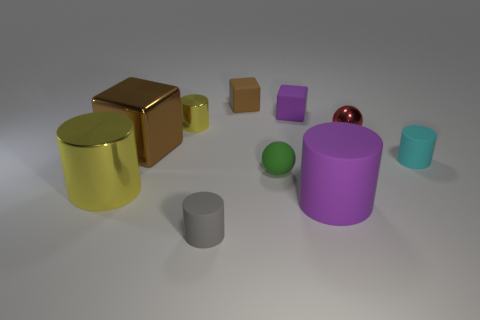There is a brown object that is right of the small yellow cylinder; what material is it?
Offer a terse response. Rubber. Are there any other things that have the same shape as the gray object?
Your answer should be compact. Yes. What number of metal objects are red spheres or yellow blocks?
Offer a very short reply. 1. Are there fewer brown blocks on the right side of the red shiny ball than cyan cylinders?
Keep it short and to the point. Yes. What shape is the yellow object that is right of the cylinder that is to the left of the brown metallic object behind the tiny cyan matte cylinder?
Ensure brevity in your answer.  Cylinder. Is the color of the small rubber sphere the same as the big metallic cylinder?
Your response must be concise. No. Are there more brown rubber things than yellow shiny things?
Your response must be concise. No. How many other things are there of the same material as the tiny gray cylinder?
Your response must be concise. 5. How many things are large cylinders or rubber objects in front of the big matte thing?
Offer a very short reply. 3. Is the number of big brown objects less than the number of small yellow matte balls?
Make the answer very short. No. 